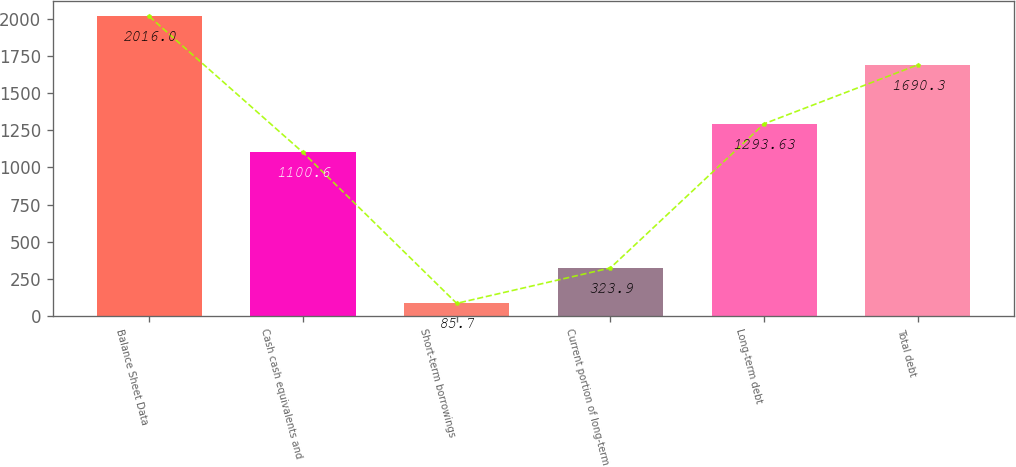<chart> <loc_0><loc_0><loc_500><loc_500><bar_chart><fcel>Balance Sheet Data<fcel>Cash cash equivalents and<fcel>Short-term borrowings<fcel>Current portion of long-term<fcel>Long-term debt<fcel>Total debt<nl><fcel>2016<fcel>1100.6<fcel>85.7<fcel>323.9<fcel>1293.63<fcel>1690.3<nl></chart> 